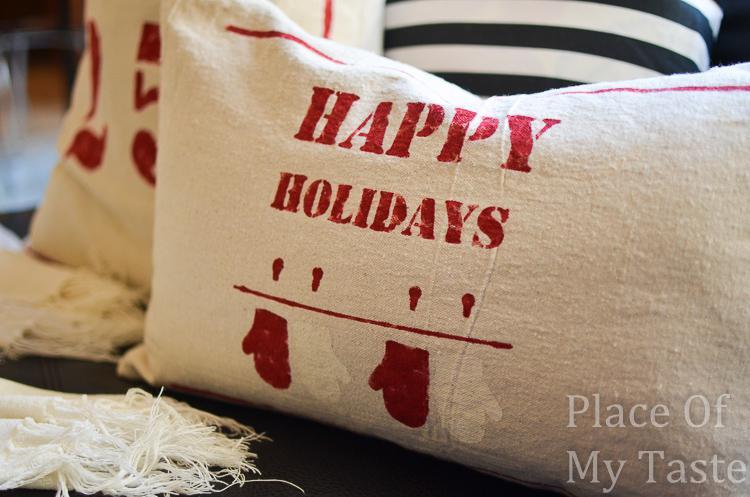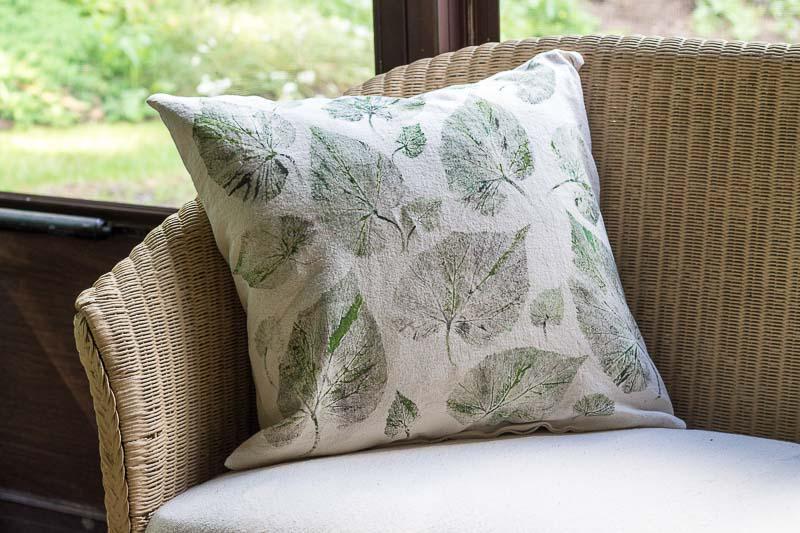The first image is the image on the left, the second image is the image on the right. Assess this claim about the two images: "The righthand image includes striped pillows and a pillow with mitten pairs stamped on it.". Correct or not? Answer yes or no. No. The first image is the image on the left, the second image is the image on the right. Examine the images to the left and right. Is the description "The right image contains at least four pillows." accurate? Answer yes or no. No. 